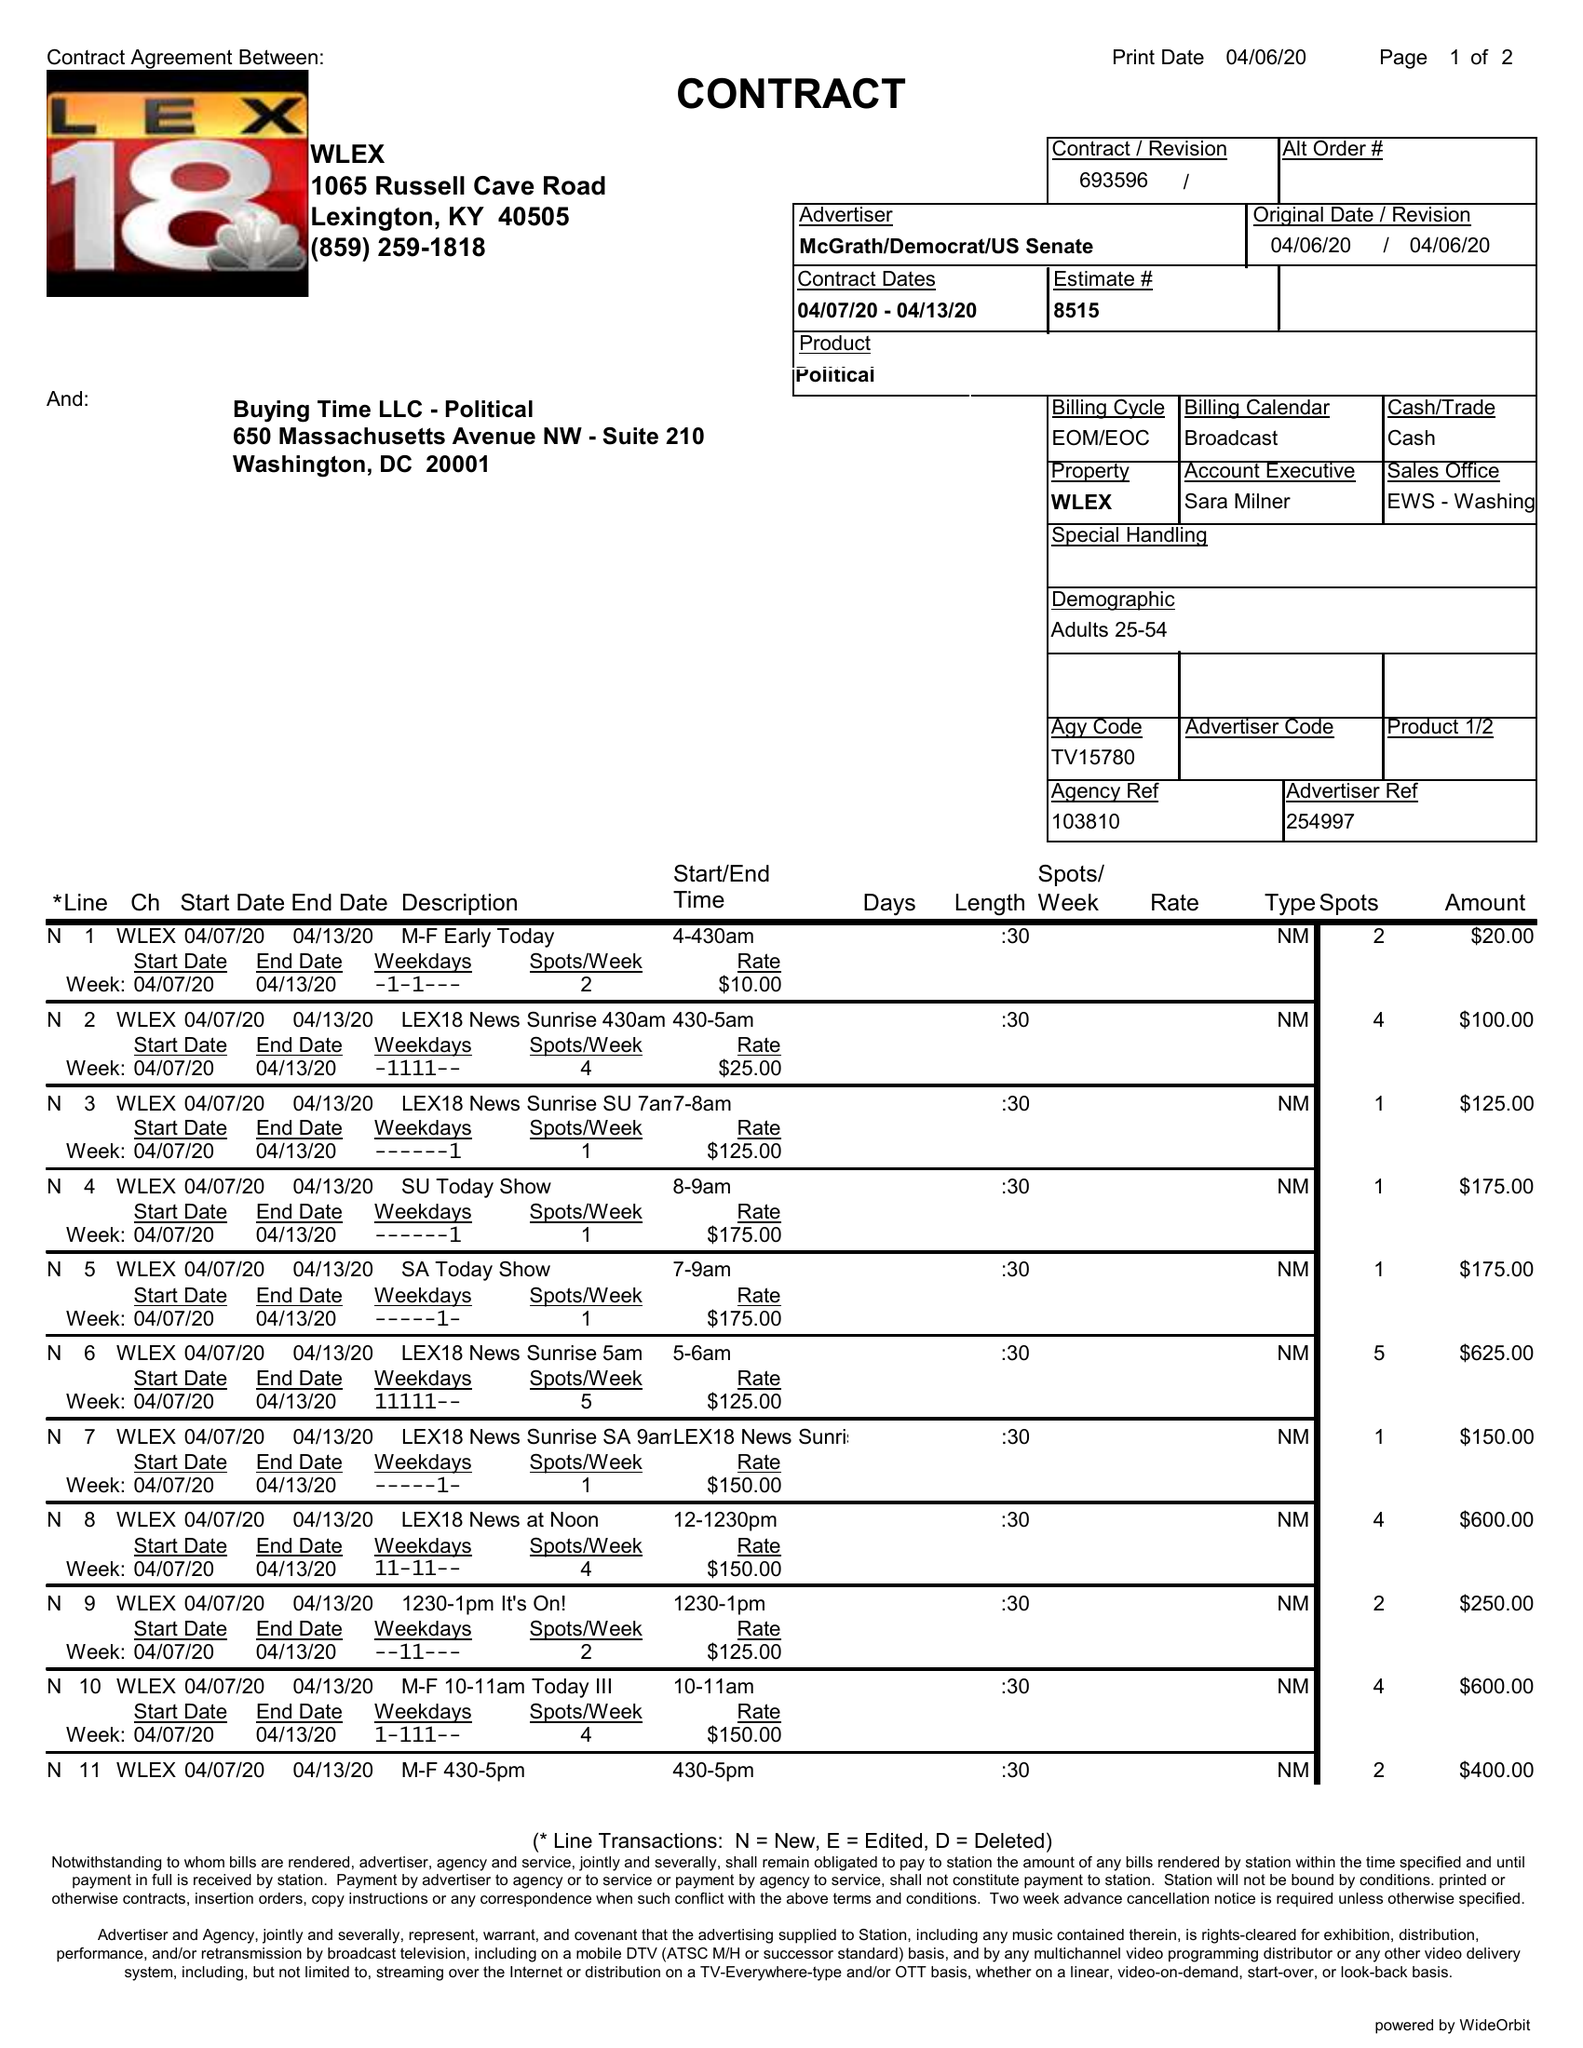What is the value for the flight_from?
Answer the question using a single word or phrase. 04/07/20 